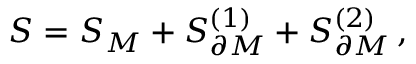Convert formula to latex. <formula><loc_0><loc_0><loc_500><loc_500>S = S _ { M } + S _ { \partial M } ^ { ( 1 ) } + S _ { \partial M } ^ { ( 2 ) } \, ,</formula> 